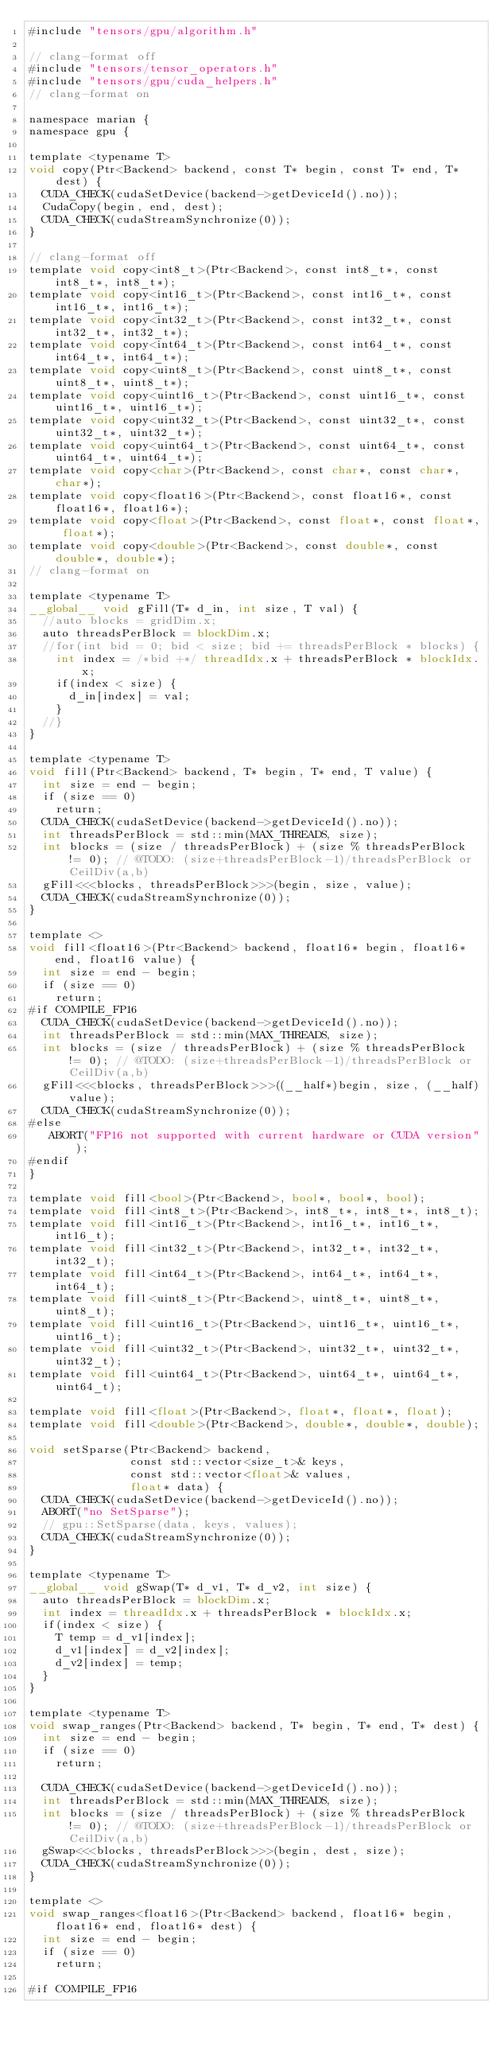<code> <loc_0><loc_0><loc_500><loc_500><_Cuda_>#include "tensors/gpu/algorithm.h"

// clang-format off
#include "tensors/tensor_operators.h"
#include "tensors/gpu/cuda_helpers.h"
// clang-format on

namespace marian {
namespace gpu {

template <typename T>
void copy(Ptr<Backend> backend, const T* begin, const T* end, T* dest) {
  CUDA_CHECK(cudaSetDevice(backend->getDeviceId().no));
  CudaCopy(begin, end, dest);
  CUDA_CHECK(cudaStreamSynchronize(0));
}

// clang-format off
template void copy<int8_t>(Ptr<Backend>, const int8_t*, const int8_t*, int8_t*);
template void copy<int16_t>(Ptr<Backend>, const int16_t*, const int16_t*, int16_t*);
template void copy<int32_t>(Ptr<Backend>, const int32_t*, const int32_t*, int32_t*);
template void copy<int64_t>(Ptr<Backend>, const int64_t*, const int64_t*, int64_t*);
template void copy<uint8_t>(Ptr<Backend>, const uint8_t*, const uint8_t*, uint8_t*);
template void copy<uint16_t>(Ptr<Backend>, const uint16_t*, const uint16_t*, uint16_t*);
template void copy<uint32_t>(Ptr<Backend>, const uint32_t*, const uint32_t*, uint32_t*);
template void copy<uint64_t>(Ptr<Backend>, const uint64_t*, const uint64_t*, uint64_t*);
template void copy<char>(Ptr<Backend>, const char*, const char*, char*);
template void copy<float16>(Ptr<Backend>, const float16*, const float16*, float16*);
template void copy<float>(Ptr<Backend>, const float*, const float*, float*);
template void copy<double>(Ptr<Backend>, const double*, const double*, double*);
// clang-format on

template <typename T>
__global__ void gFill(T* d_in, int size, T val) {
  //auto blocks = gridDim.x;
  auto threadsPerBlock = blockDim.x;
  //for(int bid = 0; bid < size; bid += threadsPerBlock * blocks) {
    int index = /*bid +*/ threadIdx.x + threadsPerBlock * blockIdx.x;
    if(index < size) {
      d_in[index] = val;
    }
  //}
}

template <typename T>
void fill(Ptr<Backend> backend, T* begin, T* end, T value) {
  int size = end - begin;
  if (size == 0)
    return;
  CUDA_CHECK(cudaSetDevice(backend->getDeviceId().no));
  int threadsPerBlock = std::min(MAX_THREADS, size);
  int blocks = (size / threadsPerBlock) + (size % threadsPerBlock != 0); // @TODO: (size+threadsPerBlock-1)/threadsPerBlock or CeilDiv(a,b)
  gFill<<<blocks, threadsPerBlock>>>(begin, size, value);
  CUDA_CHECK(cudaStreamSynchronize(0));
}

template <>
void fill<float16>(Ptr<Backend> backend, float16* begin, float16* end, float16 value) {
  int size = end - begin;
  if (size == 0)
    return;
#if COMPILE_FP16
  CUDA_CHECK(cudaSetDevice(backend->getDeviceId().no));
  int threadsPerBlock = std::min(MAX_THREADS, size);
  int blocks = (size / threadsPerBlock) + (size % threadsPerBlock != 0); // @TODO: (size+threadsPerBlock-1)/threadsPerBlock or CeilDiv(a,b)
  gFill<<<blocks, threadsPerBlock>>>((__half*)begin, size, (__half)value);
  CUDA_CHECK(cudaStreamSynchronize(0));
#else
   ABORT("FP16 not supported with current hardware or CUDA version");
#endif
}

template void fill<bool>(Ptr<Backend>, bool*, bool*, bool);
template void fill<int8_t>(Ptr<Backend>, int8_t*, int8_t*, int8_t);
template void fill<int16_t>(Ptr<Backend>, int16_t*, int16_t*, int16_t);
template void fill<int32_t>(Ptr<Backend>, int32_t*, int32_t*, int32_t);
template void fill<int64_t>(Ptr<Backend>, int64_t*, int64_t*, int64_t);
template void fill<uint8_t>(Ptr<Backend>, uint8_t*, uint8_t*, uint8_t);
template void fill<uint16_t>(Ptr<Backend>, uint16_t*, uint16_t*, uint16_t);
template void fill<uint32_t>(Ptr<Backend>, uint32_t*, uint32_t*, uint32_t);
template void fill<uint64_t>(Ptr<Backend>, uint64_t*, uint64_t*, uint64_t);

template void fill<float>(Ptr<Backend>, float*, float*, float);
template void fill<double>(Ptr<Backend>, double*, double*, double);

void setSparse(Ptr<Backend> backend,
               const std::vector<size_t>& keys,
               const std::vector<float>& values,
               float* data) {
  CUDA_CHECK(cudaSetDevice(backend->getDeviceId().no));
  ABORT("no SetSparse");
  // gpu::SetSparse(data, keys, values);
  CUDA_CHECK(cudaStreamSynchronize(0));
}

template <typename T>
__global__ void gSwap(T* d_v1, T* d_v2, int size) {
  auto threadsPerBlock = blockDim.x;
  int index = threadIdx.x + threadsPerBlock * blockIdx.x;
  if(index < size) {
    T temp = d_v1[index];
    d_v1[index] = d_v2[index];
    d_v2[index] = temp;
  }
}

template <typename T>
void swap_ranges(Ptr<Backend> backend, T* begin, T* end, T* dest) {
  int size = end - begin;
  if (size == 0)
    return;

  CUDA_CHECK(cudaSetDevice(backend->getDeviceId().no));
  int threadsPerBlock = std::min(MAX_THREADS, size);
  int blocks = (size / threadsPerBlock) + (size % threadsPerBlock != 0); // @TODO: (size+threadsPerBlock-1)/threadsPerBlock or CeilDiv(a,b)
  gSwap<<<blocks, threadsPerBlock>>>(begin, dest, size);
  CUDA_CHECK(cudaStreamSynchronize(0));
}

template <>
void swap_ranges<float16>(Ptr<Backend> backend, float16* begin, float16* end, float16* dest) {
  int size = end - begin;
  if (size == 0)
    return;

#if COMPILE_FP16</code> 